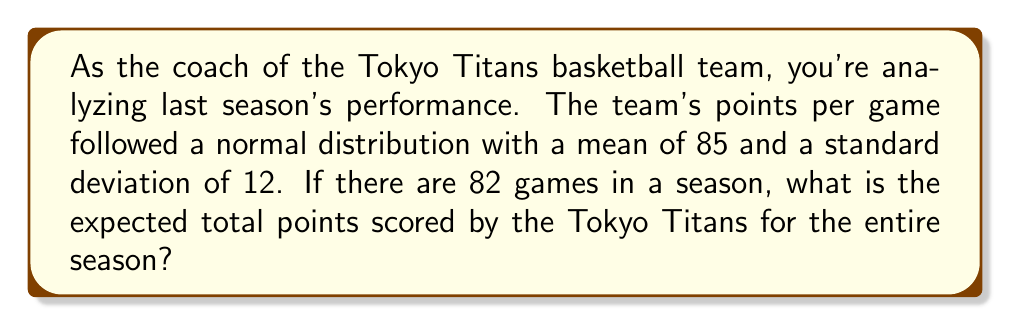Can you solve this math problem? Let's approach this step-by-step:

1) First, we need to understand what expected value means. The expected value of a random variable is its average value over a large number of trials.

2) In this case, we're dealing with a normal distribution for points per game. The expected value of a normal distribution is equal to its mean.

3) We're given that:
   - The mean points per game is 85
   - There are 82 games in a season

4) To find the expected total points for the season, we multiply the expected points per game by the number of games:

   $$E(\text{Total Points}) = E(\text{Points per Game}) \times \text{Number of Games}$$

5) Substituting the values:

   $$E(\text{Total Points}) = 85 \times 82 = 6970$$

6) Note that the standard deviation doesn't affect the expected value calculation, but it would be relevant if we were calculating probabilities or confidence intervals.
Answer: 6970 points 